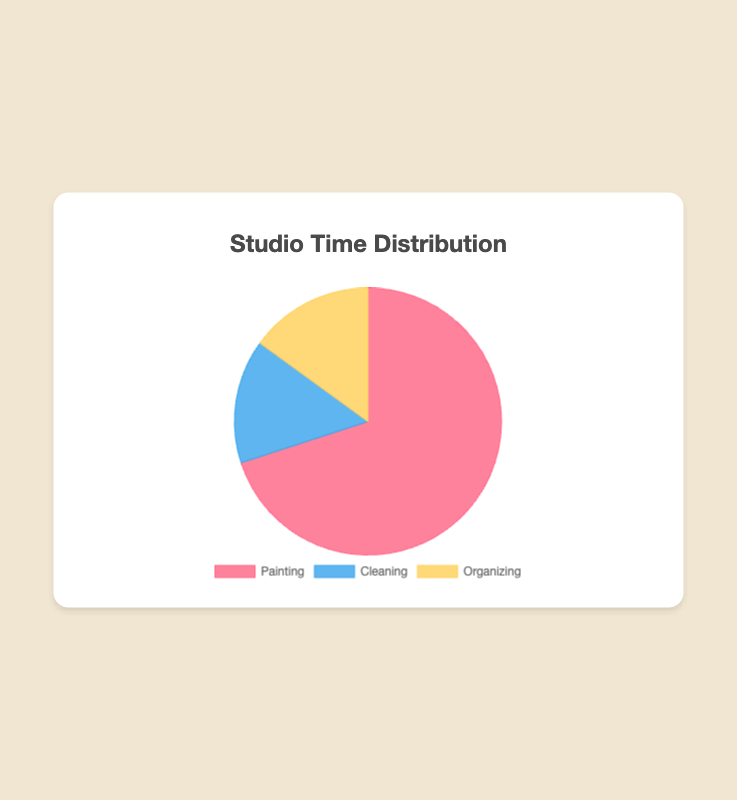How much time is spent on non-painting activities in total? To find out the total time spent on non-painting activities, we sum up the time spent on cleaning and organizing. Therefore, Cleaning (15) + Organizing (15) = 30.
Answer: 30 Which activity occupies the largest portion of time in the studio? By examining the chart, it's clear that Painting has the highest percentage at 70%.
Answer: Painting Is the time spent on cleaning equal to the time spent on organizing? Referring to the pie chart, Cleaning and Organizing both represent 15% of the time, making them equal.
Answer: Yes What is the difference in time spent between painting and organizing? To find the difference, we subtract the time spent organizing from the time spent painting: Painting (70) - Organizing (15) = 55.
Answer: 55 By what factor is the time spent on painting greater than the time spent on cleaning? To find this, we divide the time spent on painting by the time spent on cleaning: Painting (70) ÷ Cleaning (15) = 4.67.
Answer: 4.67 What percentage of the time in the studio is spent on painting compared to the total of cleaning and organizing? The total time for cleaning and organizing: 15 + 15 = 30. The percentage for painting is: (70 / (70 + 30)) * 100 = 70%.
Answer: 70% What color represents organizing time on the chart? By looking at the chart, Organizing time is represented by yellow.
Answer: Yellow Which two activities take up an equal amount of time? Referring to the pie chart, both Cleaning and Organizing each take up 15% of the time.
Answer: Cleaning and Organizing 